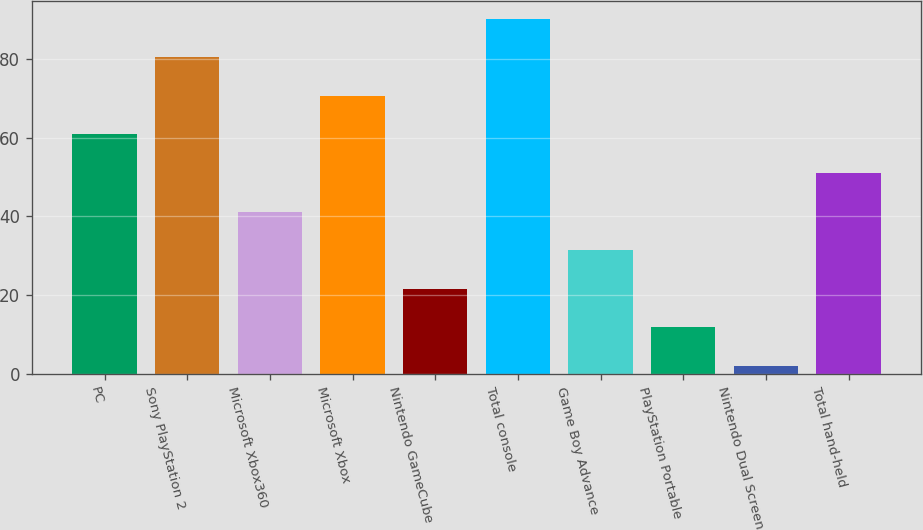<chart> <loc_0><loc_0><loc_500><loc_500><bar_chart><fcel>PC<fcel>Sony PlayStation 2<fcel>Microsoft Xbox360<fcel>Microsoft Xbox<fcel>Nintendo GameCube<fcel>Total console<fcel>Game Boy Advance<fcel>PlayStation Portable<fcel>Nintendo Dual Screen<fcel>Total hand-held<nl><fcel>60.8<fcel>80.4<fcel>41.2<fcel>70.6<fcel>21.6<fcel>90.2<fcel>31.4<fcel>11.8<fcel>2<fcel>51<nl></chart> 